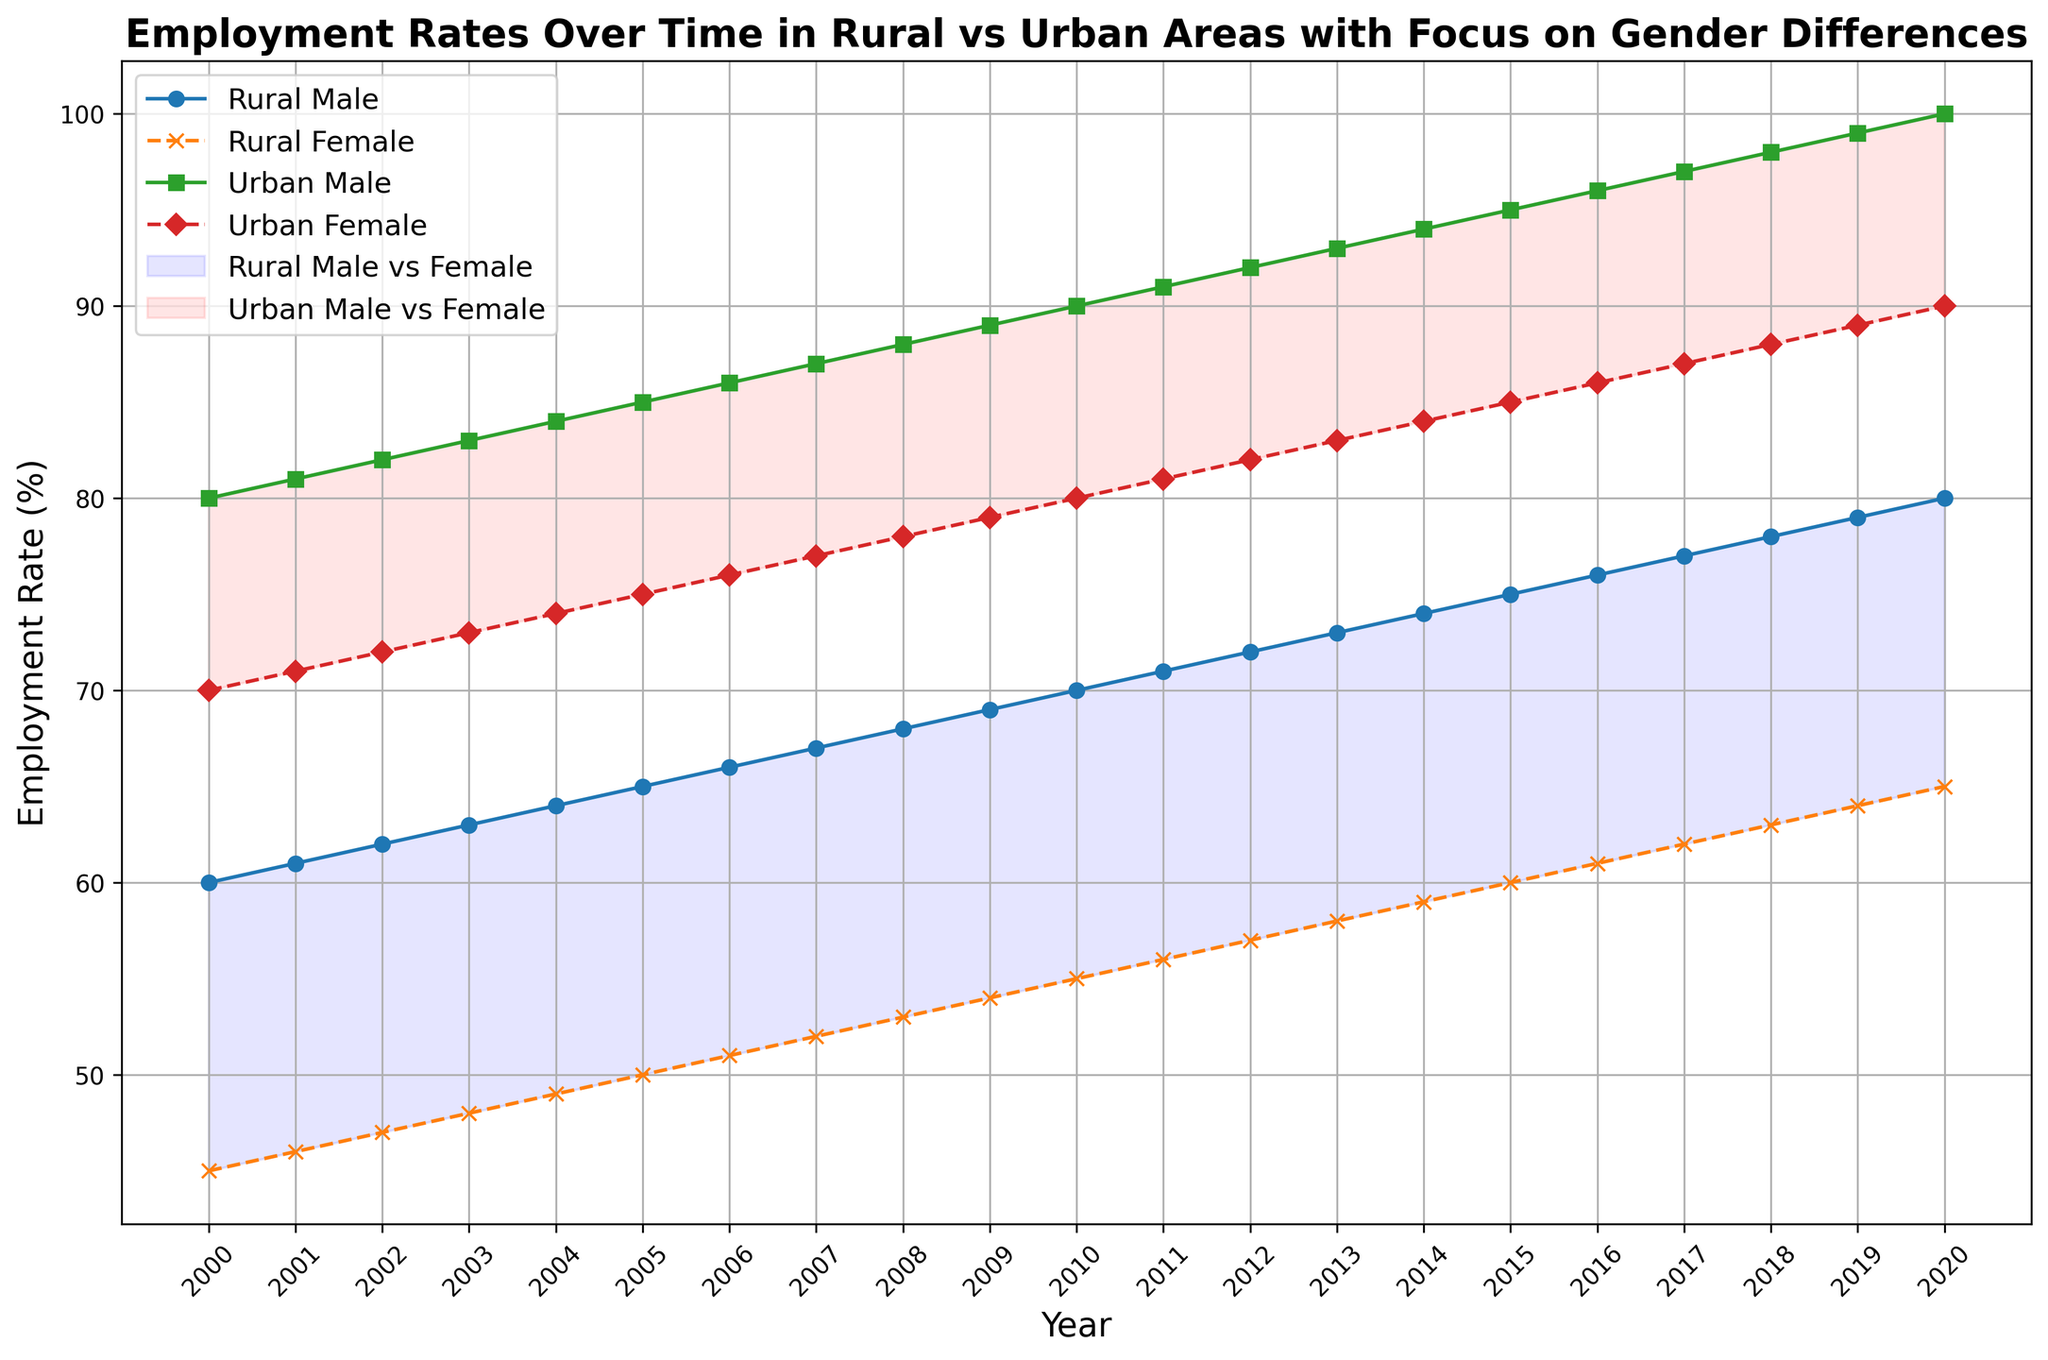What trends do you observe in the employment rates of rural males and females over time? Observing the plot, both rural males and females show a gradual increase in employment rates over the years. Rural males have a higher employment rate than rural females throughout the period. The trend lines for both genders rise steadily from 2000 to 2020.
Answer: Gradual increase for both; higher for males In which year is the gap between urban male and urban female employment rates the smallest? The gap between urban male and female employment rates is represented by the height of the filled area (red). Visually, the gap seems to be consistent, with a clear 10% difference every year.
Answer: Consistent gap of 10%, no year with smaller gap Who had a higher employment rate in 2015, rural females or urban males? And by how much? In 2015, the employment rate for rural females is 60%, whereas for urban males, it is 95%. The difference is calculated by subtracting 60% from 95%.
Answer: Urban males by 35% What is the overall trend difference between urban males and rural males? Urban males exhibit a consistently higher employment rate compared to rural males throughout the years. While both show an increasing trend, the employment rate for urban males increases more sharply and stays higher. The gap also widens over time, especially visible from the steeper slope in the plot for urban males.
Answer: Urban males increase more sharply and stay higher Compare the employment rates of urban females in 2005 and 2020. In 2005, the employment rate for urban females is 75%, and in 2020, it is 90%. Subtracting these two values gives the increase in employment rate over this period.
Answer: Increased by 15% Between which years did rural males show the most significant annual increase in employment rate, and how much was the increase? To identify the most significant annual increase, we compare the employment rates year-over-year for rural males. The increase from 69% in 2009 to 70% in 2010 is the largest observed increase of 1%.
Answer: 2009 to 2010, 1% What is the average employment rate for urban females over the period? We sum the employment rates for urban females from 2000 to 2020 and divide by the number of years (21). This equates to (70% + 71% + 72% + 73% + 74% + 75% + 76% + 77% + 78% + 79% + 80% + 81% + 82% + 83% + 84% + 85% + 86% + 87% + 88% + 89% + 90%)/21.
Answer: 80% How much did the employment rate for rural females increase from 2000 to 2020? To find the increase, subtract the employment rate for rural females in 2000 (45%) from their rate in 2020 (65%). This gives the total increase over the period.
Answer: Increased by 20% Who had a lower employment rate in 2003, urban females or rural males? According to the plot, the employment rate for urban females in 2003 is 73%, and for rural males, it is 63%. Therefore, rural males had a lower employment rate in that year.
Answer: Rural males If you average the employment rates for rural females in the years 2000, 2005, 2010, 2015, and 2020, what is the result? The employment rates for rural females in the given years are: 2000 (45%), 2005 (50%), 2010 (55%), 2015 (60%), and 2020 (65%). Summing these up: 45 + 50 + 55 + 60 + 65 = 275. The average is then 275 / 5.
Answer: 55% 